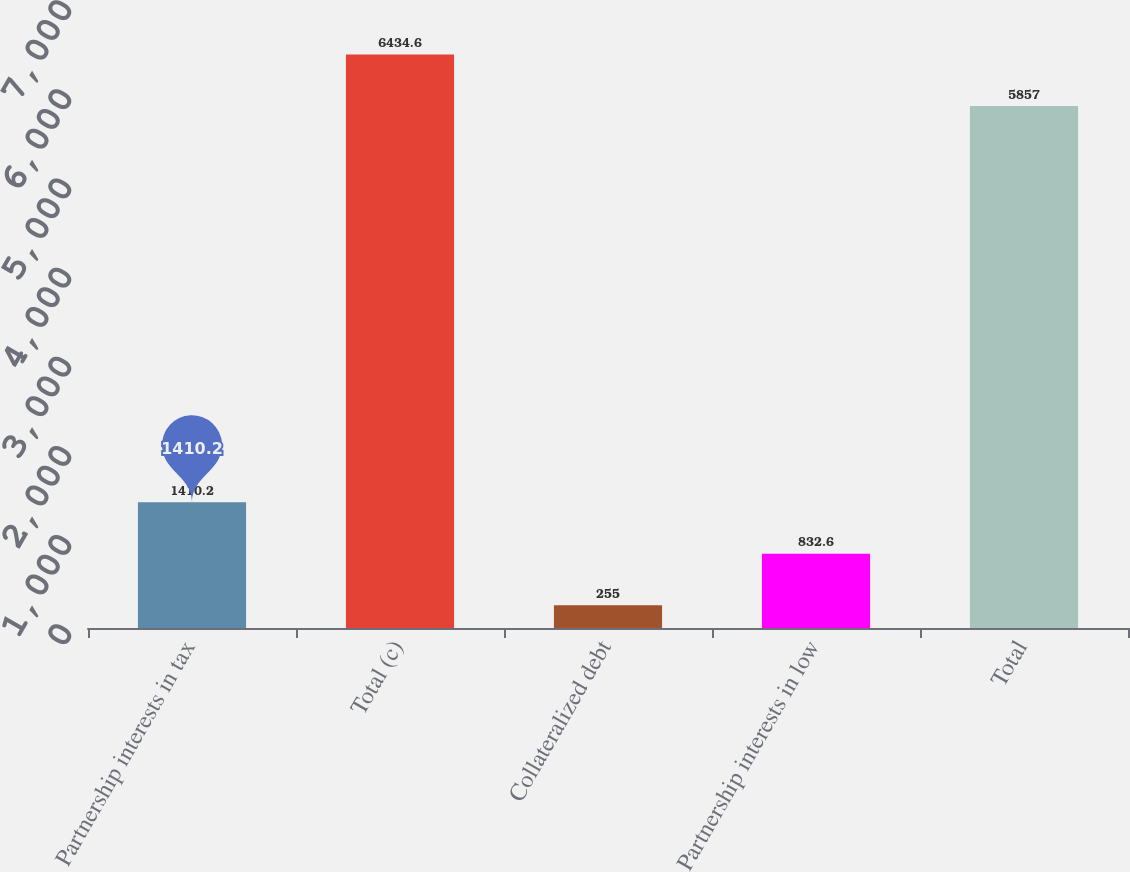Convert chart. <chart><loc_0><loc_0><loc_500><loc_500><bar_chart><fcel>Partnership interests in tax<fcel>Total (c)<fcel>Collateralized debt<fcel>Partnership interests in low<fcel>Total<nl><fcel>1410.2<fcel>6434.6<fcel>255<fcel>832.6<fcel>5857<nl></chart> 